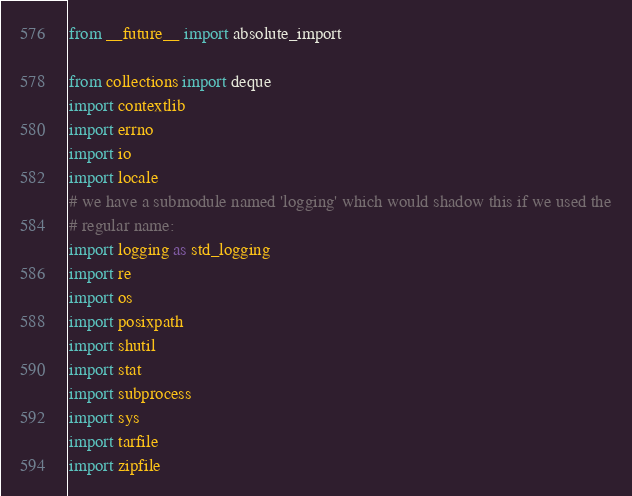<code> <loc_0><loc_0><loc_500><loc_500><_Python_>from __future__ import absolute_import

from collections import deque
import contextlib
import errno
import io
import locale
# we have a submodule named 'logging' which would shadow this if we used the
# regular name:
import logging as std_logging
import re
import os
import posixpath
import shutil
import stat
import subprocess
import sys
import tarfile
import zipfile</code> 